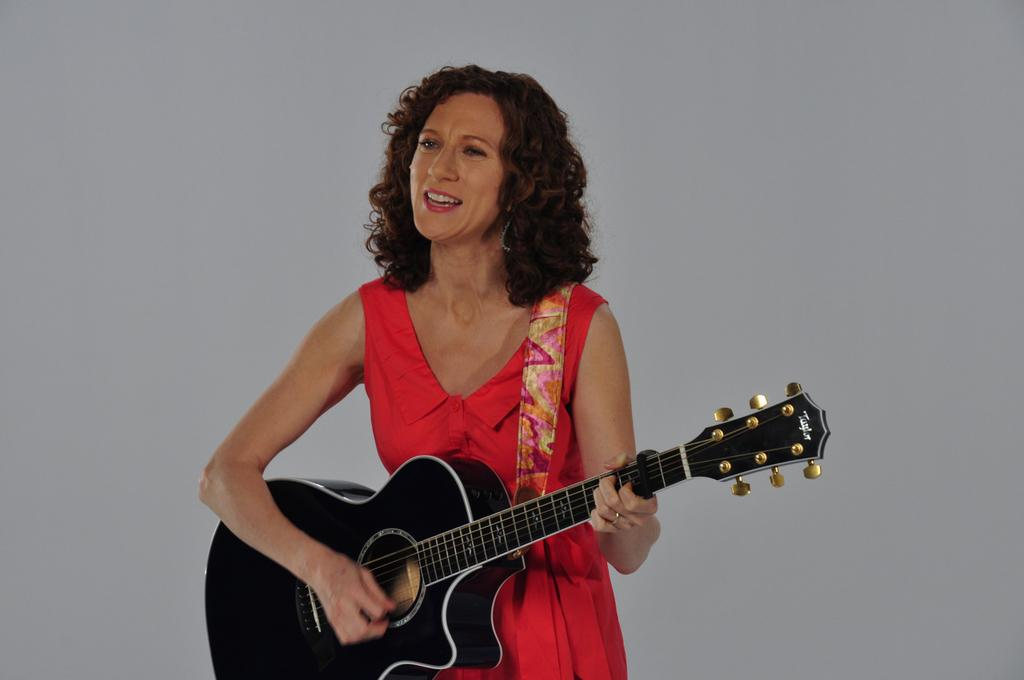What is the woman doing in the image? She is playing the violin. How is she holding the violin? She is holding the violin. Where is she standing in the image? She is standing in the middle of the stage. What is she smelling? The provided facts do not mention what she is smelling. What color is the dress she is wearing? She is wearing a red color dress. What type of balls is she juggling while playing the violin? There is no mention of balls or juggling in the image; she is only playing the violin. Is there an airplane visible in the image? No, there is no airplane present in the image. What type of work does the secretary do in the image? There is no secretary mentioned or visible in the image. 